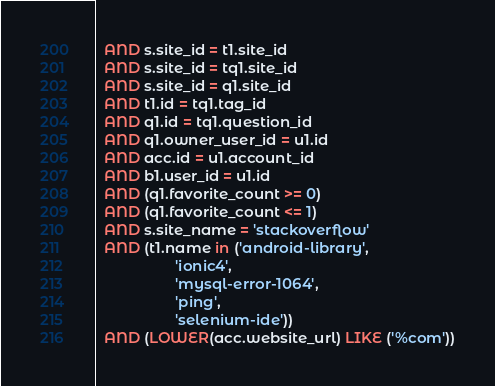<code> <loc_0><loc_0><loc_500><loc_500><_SQL_>  AND s.site_id = t1.site_id
  AND s.site_id = tq1.site_id
  AND s.site_id = q1.site_id
  AND t1.id = tq1.tag_id
  AND q1.id = tq1.question_id
  AND q1.owner_user_id = u1.id
  AND acc.id = u1.account_id
  AND b1.user_id = u1.id
  AND (q1.favorite_count >= 0)
  AND (q1.favorite_count <= 1)
  AND s.site_name = 'stackoverflow'
  AND (t1.name in ('android-library',
                   'ionic4',
                   'mysql-error-1064',
                   'ping',
                   'selenium-ide'))
  AND (LOWER(acc.website_url) LIKE ('%com'))</code> 